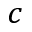<formula> <loc_0><loc_0><loc_500><loc_500>c</formula> 